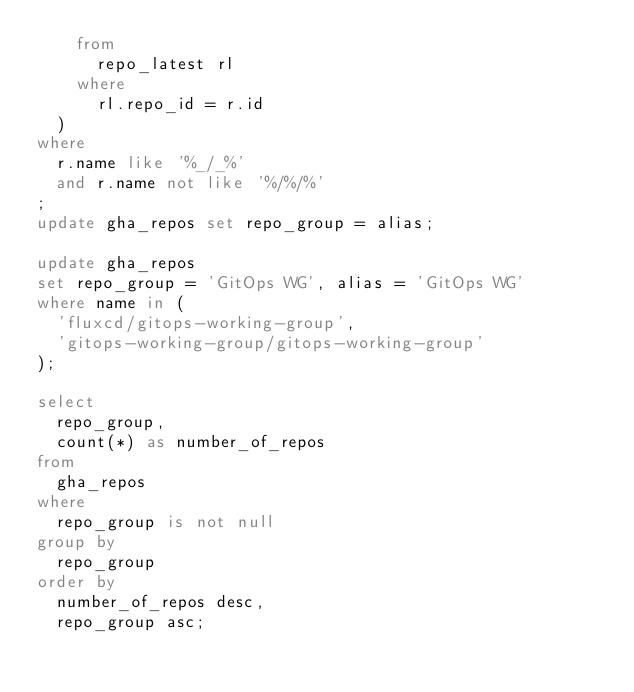<code> <loc_0><loc_0><loc_500><loc_500><_SQL_>    from
      repo_latest rl
    where
      rl.repo_id = r.id
  )
where
  r.name like '%_/_%'
  and r.name not like '%/%/%'
;
update gha_repos set repo_group = alias;

update gha_repos
set repo_group = 'GitOps WG', alias = 'GitOps WG'
where name in (
  'fluxcd/gitops-working-group',
  'gitops-working-group/gitops-working-group'
);

select
  repo_group,
  count(*) as number_of_repos
from
  gha_repos
where
  repo_group is not null
group by
  repo_group
order by
  number_of_repos desc,
  repo_group asc;
</code> 